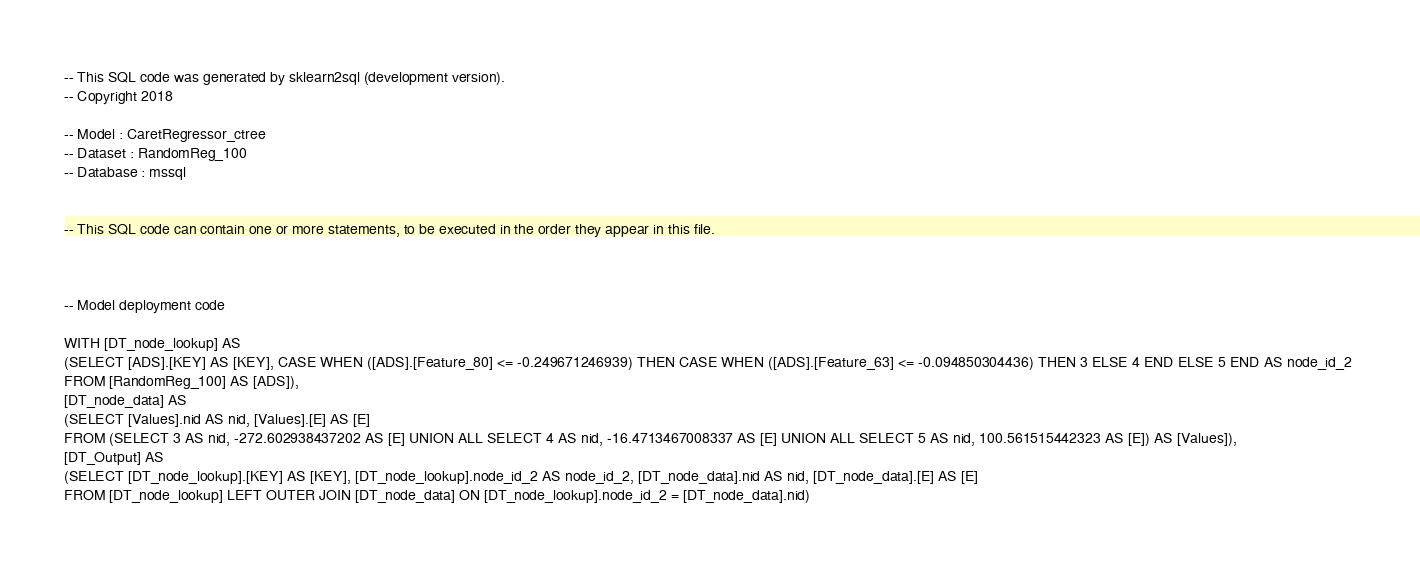Convert code to text. <code><loc_0><loc_0><loc_500><loc_500><_SQL_>-- This SQL code was generated by sklearn2sql (development version).
-- Copyright 2018

-- Model : CaretRegressor_ctree
-- Dataset : RandomReg_100
-- Database : mssql


-- This SQL code can contain one or more statements, to be executed in the order they appear in this file.



-- Model deployment code

WITH [DT_node_lookup] AS 
(SELECT [ADS].[KEY] AS [KEY], CASE WHEN ([ADS].[Feature_80] <= -0.249671246939) THEN CASE WHEN ([ADS].[Feature_63] <= -0.094850304436) THEN 3 ELSE 4 END ELSE 5 END AS node_id_2 
FROM [RandomReg_100] AS [ADS]), 
[DT_node_data] AS 
(SELECT [Values].nid AS nid, [Values].[E] AS [E] 
FROM (SELECT 3 AS nid, -272.602938437202 AS [E] UNION ALL SELECT 4 AS nid, -16.4713467008337 AS [E] UNION ALL SELECT 5 AS nid, 100.561515442323 AS [E]) AS [Values]), 
[DT_Output] AS 
(SELECT [DT_node_lookup].[KEY] AS [KEY], [DT_node_lookup].node_id_2 AS node_id_2, [DT_node_data].nid AS nid, [DT_node_data].[E] AS [E] 
FROM [DT_node_lookup] LEFT OUTER JOIN [DT_node_data] ON [DT_node_lookup].node_id_2 = [DT_node_data].nid)</code> 